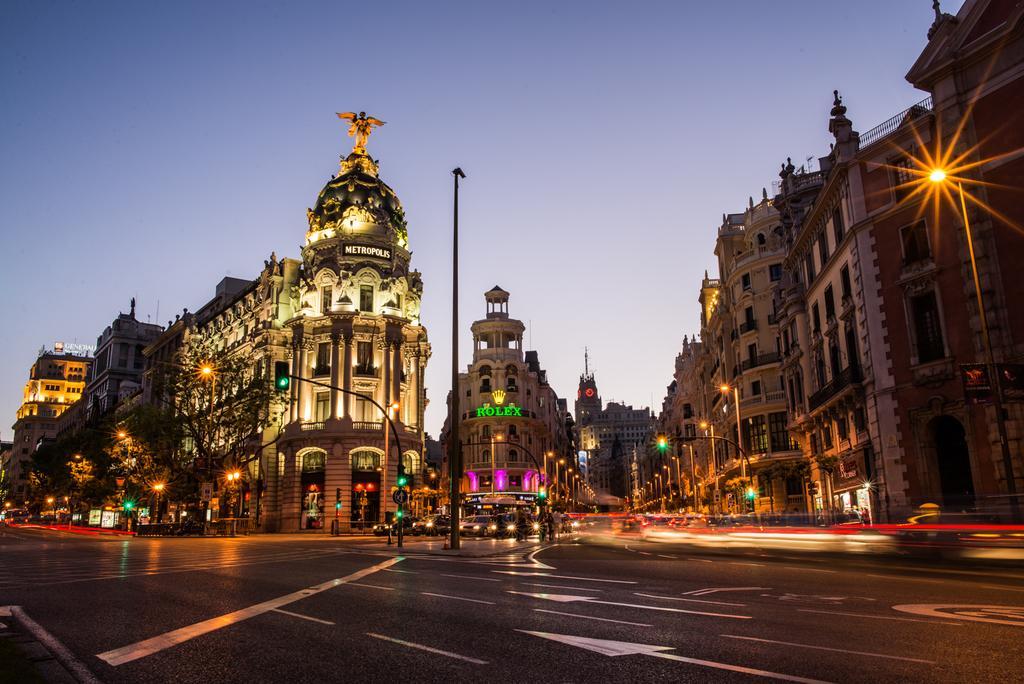Describe this image in one or two sentences. This image is clicked on the road. At the bottom, there is a road. In the front, there are many buildings along with the lights. In the middle, there is a pole. And we can see many vehicles and few people on the road. At the top, there is sky. 